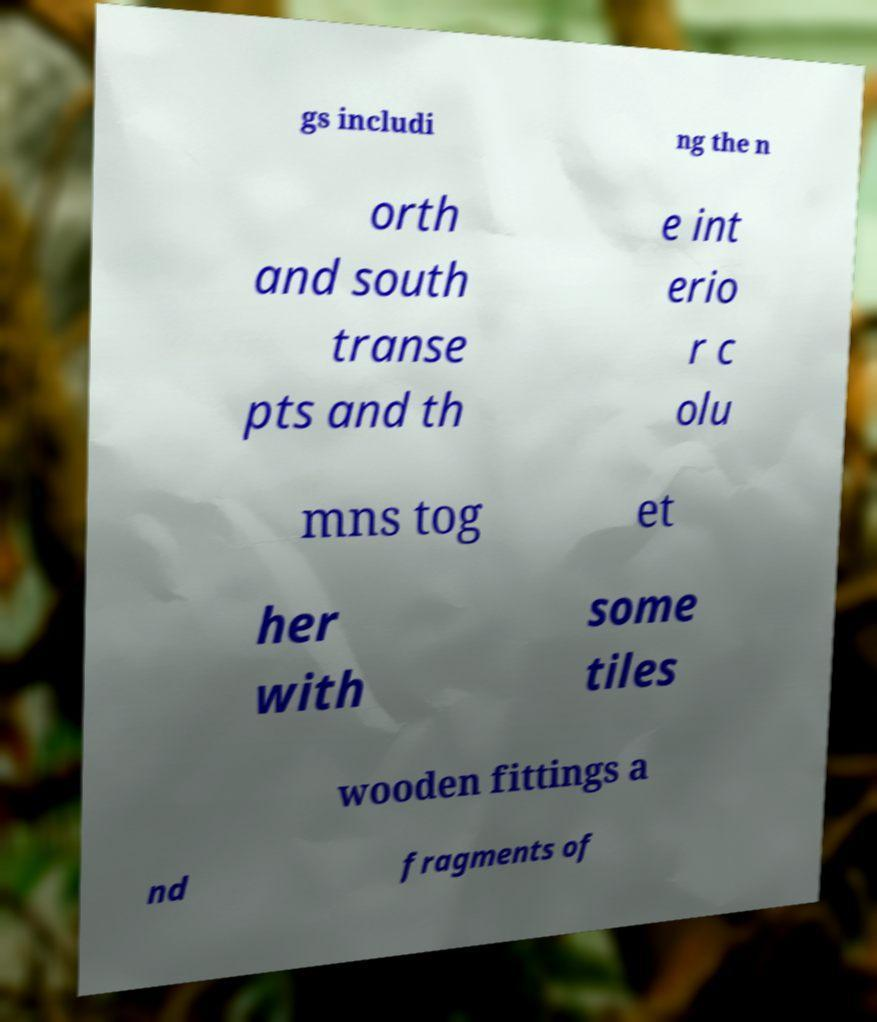There's text embedded in this image that I need extracted. Can you transcribe it verbatim? gs includi ng the n orth and south transe pts and th e int erio r c olu mns tog et her with some tiles wooden fittings a nd fragments of 